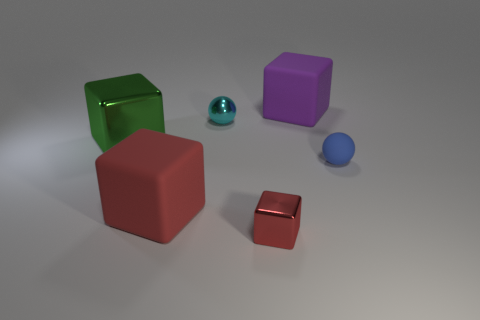What is the shape of the large purple object that is on the right side of the metallic cube that is behind the thing in front of the big red matte object?
Provide a succinct answer. Cube. There is a rubber object that is the same color as the tiny cube; what is its shape?
Offer a terse response. Cube. There is a cube that is both behind the tiny blue ball and on the left side of the cyan sphere; what material is it made of?
Make the answer very short. Metal. Is the number of tiny purple matte balls less than the number of tiny blue matte balls?
Give a very brief answer. Yes. There is a blue object; is its shape the same as the tiny object to the left of the small red metal block?
Ensure brevity in your answer.  Yes. Do the matte object behind the blue thing and the large red block have the same size?
Ensure brevity in your answer.  Yes. The red object that is the same size as the blue matte thing is what shape?
Your answer should be very brief. Cube. Is the shape of the green thing the same as the tiny blue matte thing?
Your answer should be compact. No. How many small cyan metal things are the same shape as the large green thing?
Your response must be concise. 0. What number of purple blocks are in front of the small cyan ball?
Ensure brevity in your answer.  0. 